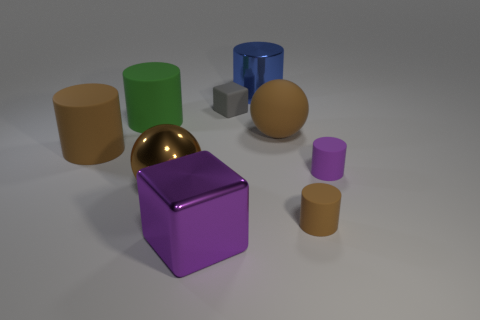Add 1 big blue metallic cylinders. How many objects exist? 10 Subtract all big green cylinders. How many cylinders are left? 4 Subtract all purple cubes. How many cubes are left? 1 Subtract all cubes. How many objects are left? 7 Subtract all yellow blocks. How many brown cylinders are left? 2 Subtract 2 cylinders. How many cylinders are left? 3 Subtract all brown cylinders. Subtract all purple balls. How many cylinders are left? 3 Subtract all tiny gray matte blocks. Subtract all brown matte cylinders. How many objects are left? 6 Add 1 big brown matte cylinders. How many big brown matte cylinders are left? 2 Add 3 shiny objects. How many shiny objects exist? 6 